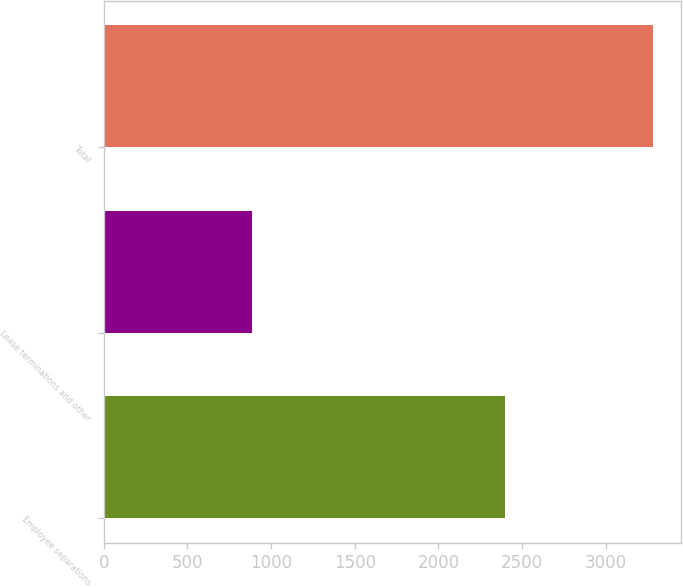Convert chart to OTSL. <chart><loc_0><loc_0><loc_500><loc_500><bar_chart><fcel>Employee separations<fcel>Lease terminations and other<fcel>Total<nl><fcel>2397<fcel>888<fcel>3285<nl></chart> 